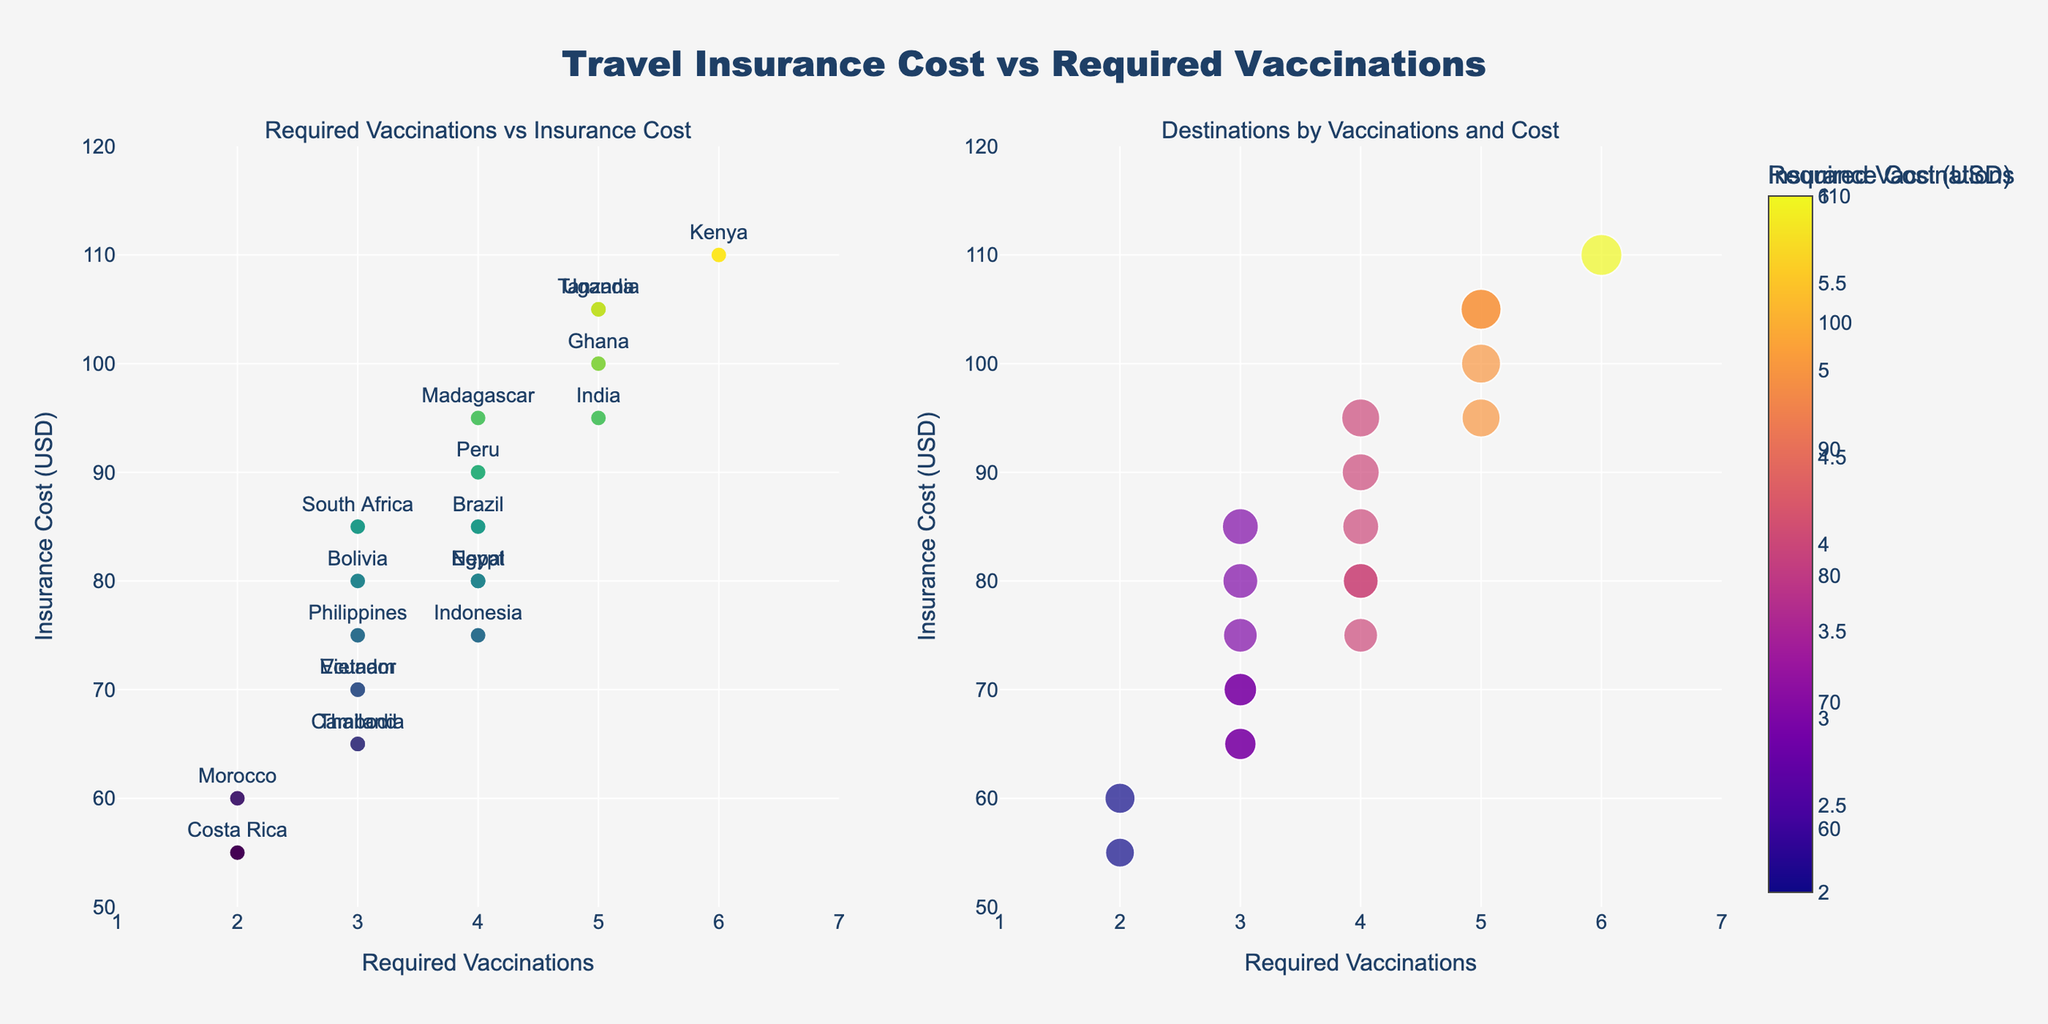What's the title of the figure? The title is prominently displayed at the top of the figure. It reads "Travel Insurance Cost vs Required Vaccinations."
Answer: Travel Insurance Cost vs Required Vaccinations Which destination requires the most vaccinations? By observing the scatter plot, the destination with the highest number of required vaccinations (6) is Kenya. The label next to this data point corresponds to Kenya.
Answer: Kenya How many destinations are shown in the figure? Each data point in both subplots represents a destination. Counting the destinations, we see there are 20 data points.
Answer: 20 What's the range of insurance cost in the scatter plot? Insurance costs in the scatter plot range from $55, observed for Costa Rica, to $110, observed for Kenya and Uganda. These are the minimum and maximum y-axis values in the plot.
Answer: $55 to $110 Which destination has the highest insurance cost and how many vaccinations does it require? Kenya and Uganda both have the highest insurance cost ($110). Each of these destinations requires 6 and 5 vaccinations, respectively.
Answer: Kenya (6 vaccinations) and Uganda (5 vaccinations) Which two destinations require the same number of vaccinations but have a different insurance cost? Peru and Egypt both require 4 vaccinations. However, Peru's insurance cost is $90, while Egypt's is $80.
Answer: Peru and Egypt Compare the insurance cost for Morocco and Costa Rica. Which is higher and by how much? Morocco has an insurance cost of $60, while Costa Rica has an insurance cost of $55. Therefore, Morocco's insurance cost is higher by $5.
Answer: Morocco, by $5 What's the average insurance cost across all destinations with 3 required vaccinations? The destinations with 3 required vaccinations are Thailand, Vietnam, South Africa, Cambodia, Ecuador, Philippines, and Bolivia. Their costs are $65, $70, $85, $65, $70, $75, and $80. The average is (65 + 70 + 85 + 65 + 70 + 75 + 80)/7 = $72.14.
Answer: $72.14 Which destination is represented by the largest bubble in the bubble plot? The size of the bubble is proportional to the insurance cost. The largest bubbles are for Kenya and Uganda, each with an insurance cost of $110.
Answer: Kenya and Uganda What’s the color scale used for the markers in the scatter plot? The scatter plot uses the Viridis color scale, as indicated by the color of the markers. The color bar also supports this.
Answer: Viridis 